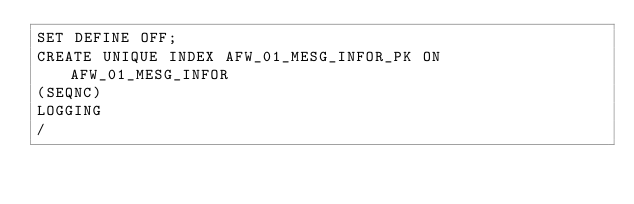Convert code to text. <code><loc_0><loc_0><loc_500><loc_500><_SQL_>SET DEFINE OFF;
CREATE UNIQUE INDEX AFW_01_MESG_INFOR_PK ON AFW_01_MESG_INFOR
(SEQNC)
LOGGING
/
</code> 